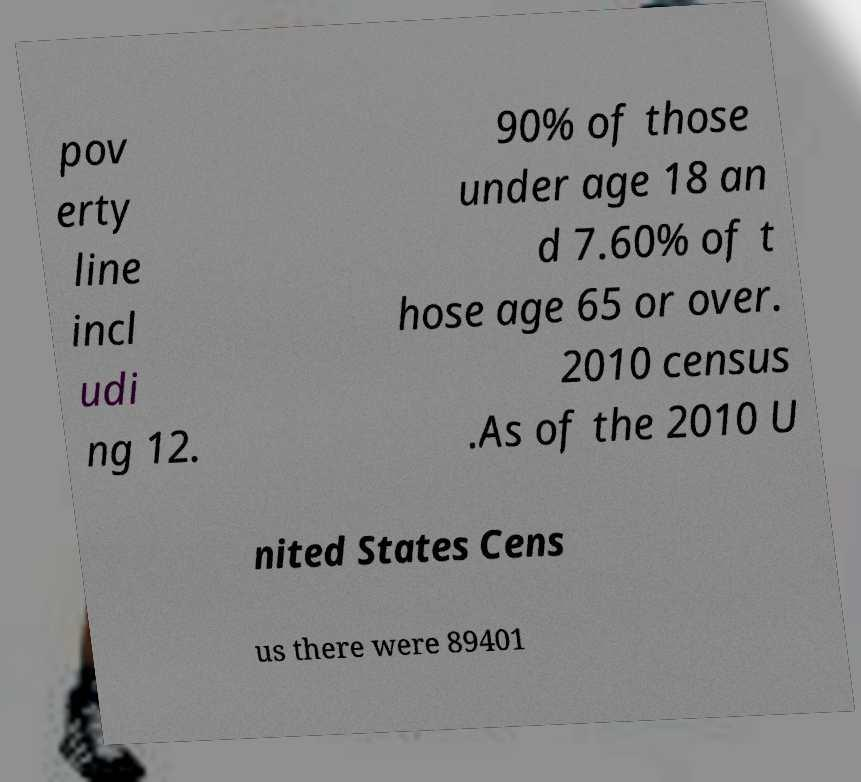Could you assist in decoding the text presented in this image and type it out clearly? pov erty line incl udi ng 12. 90% of those under age 18 an d 7.60% of t hose age 65 or over. 2010 census .As of the 2010 U nited States Cens us there were 89401 